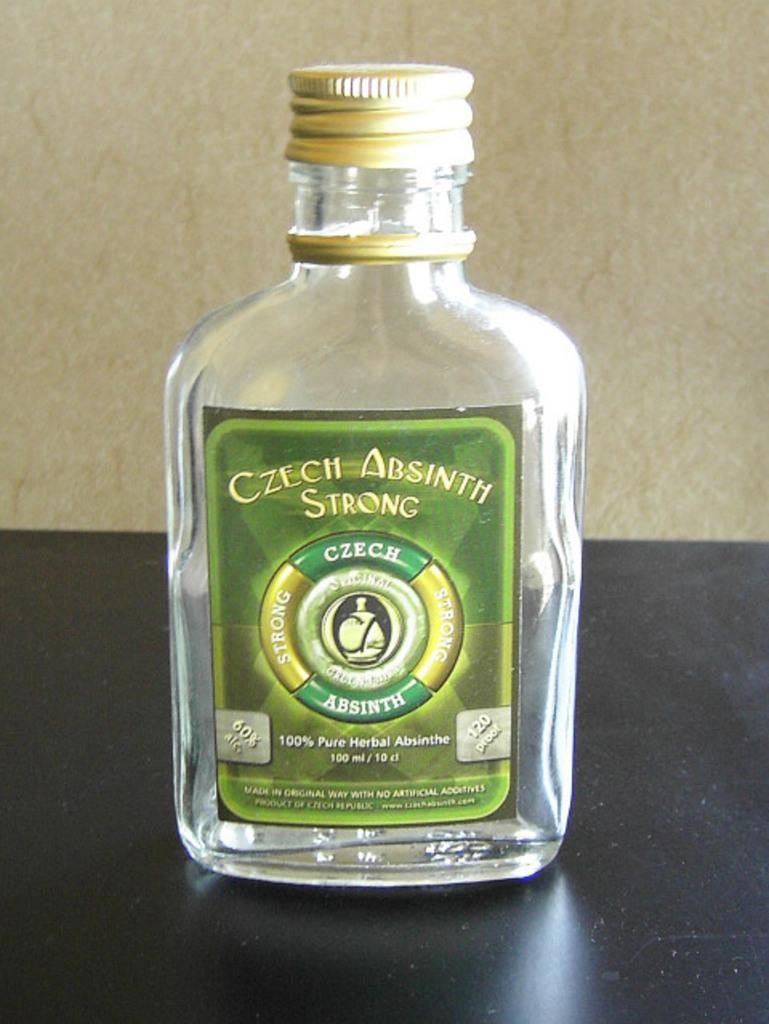<image>
Summarize the visual content of the image. A 110 ml bottle of absinth sits on a black counter. 